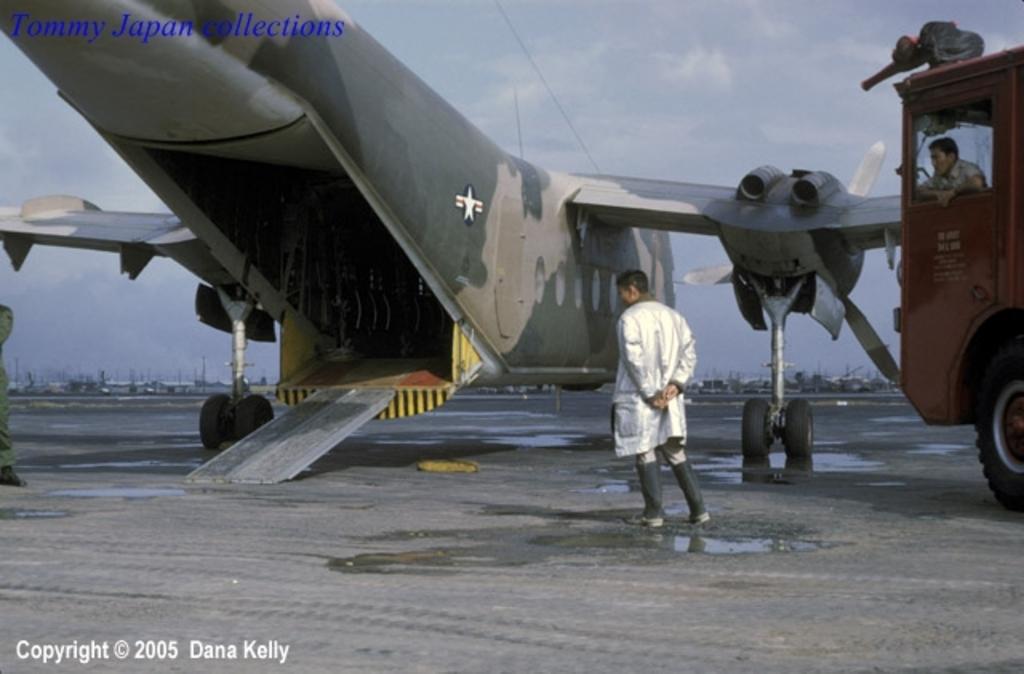Please provide a concise description of this image. This picture shows a aircraft and we see a man standing, He wore a coat and we see a vehicle on the side and a man seated in it and we see few boats and a blue cloudy sky. 